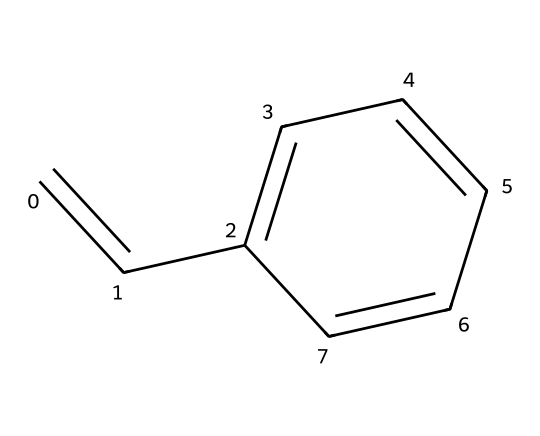What is the name of this chemical? The provided SMILES representation corresponds to the structure of styrene, which is widely known in plastic production.
Answer: styrene How many carbon atoms are in the structure? By analyzing the SMILES representation, we can see that there are eight carbon atoms present in the structure. Count each "C" in the SMILES; we find a total of 8.
Answer: 8 How many double bonds are present in this chemical structure? The chemical structure contains one double bond between the first and second carbon (C=C) in the chain and a double bond between the fifth and sixth carbon in the benzene ring, which gives us a total of two double bonds.
Answer: 2 What type of monomer is styrene classified as? Styrene is classified as an alkenyl aromatic monomer due to the presence of both a vinyl group and a benzene ring in its structure.
Answer: alkenyl aromatic What is the degree of unsaturation in this compound? The degree of unsaturation can be calculated by considering the number of rings and double bonds. Styrene contains one ring and two double bonds, leading to a total degree of unsaturation of three.
Answer: 3 How many hydrogen atoms are attached to the structure? In the case of styrene, considering the molecular formula C8H8 derived from the structure, there are eight hydrogen atoms attached to the carbon skeleton.
Answer: 8 What functional group is primarily associated with styrene? The primary functional group associated with styrene is the vinyl group, which is represented by the C=C portion of the structure, indicating styrene's reactivity in polymerization.
Answer: vinyl 